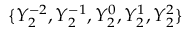<formula> <loc_0><loc_0><loc_500><loc_500>\{ Y _ { 2 } ^ { - 2 } , Y _ { 2 } ^ { - 1 } , Y _ { 2 } ^ { 0 } , Y _ { 2 } ^ { 1 } , Y _ { 2 } ^ { 2 } \}</formula> 